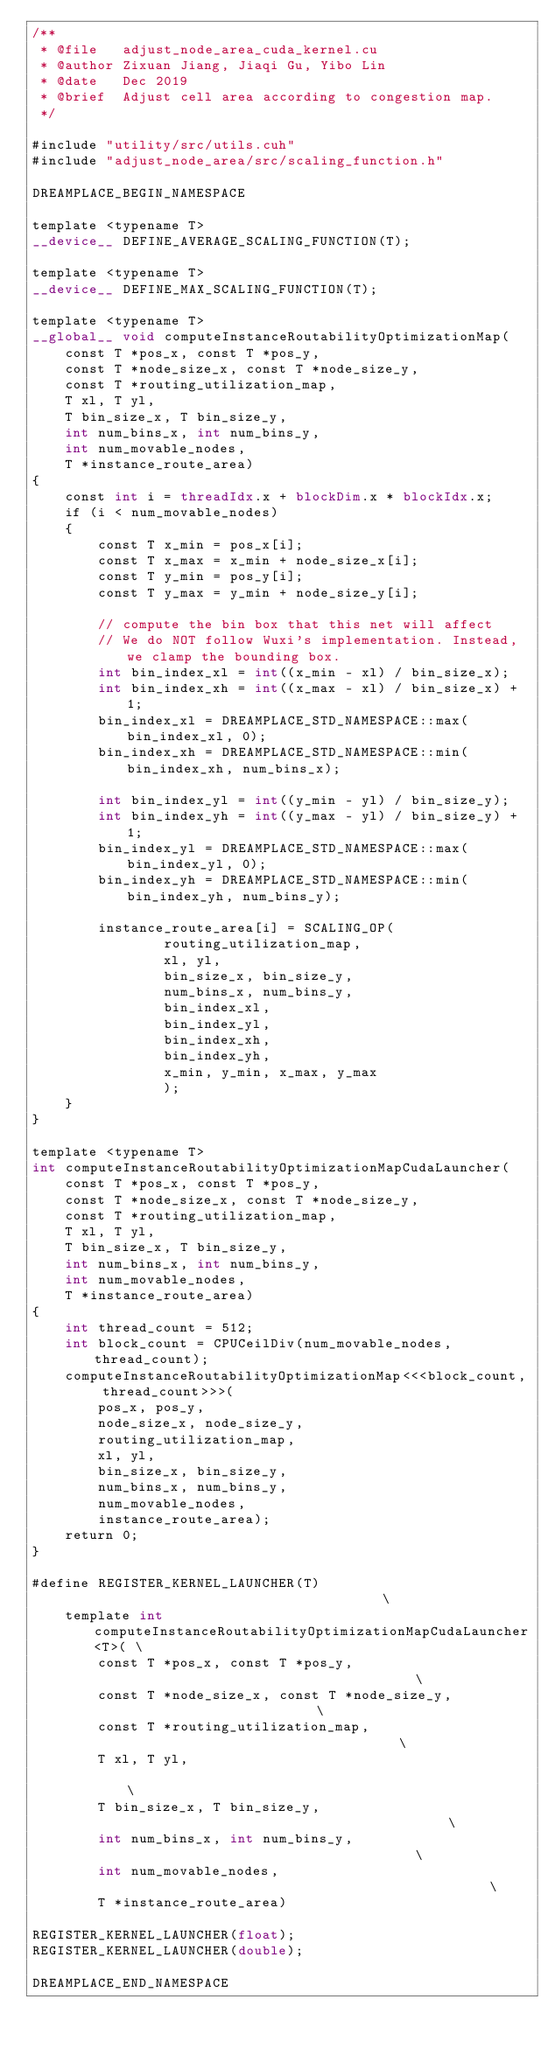<code> <loc_0><loc_0><loc_500><loc_500><_Cuda_>/**
 * @file   adjust_node_area_cuda_kernel.cu
 * @author Zixuan Jiang, Jiaqi Gu, Yibo Lin
 * @date   Dec 2019
 * @brief  Adjust cell area according to congestion map.
 */

#include "utility/src/utils.cuh"
#include "adjust_node_area/src/scaling_function.h"

DREAMPLACE_BEGIN_NAMESPACE

template <typename T>
__device__ DEFINE_AVERAGE_SCALING_FUNCTION(T); 

template <typename T>
__device__ DEFINE_MAX_SCALING_FUNCTION(T); 

template <typename T>
__global__ void computeInstanceRoutabilityOptimizationMap(
    const T *pos_x, const T *pos_y,
    const T *node_size_x, const T *node_size_y,
    const T *routing_utilization_map,
    T xl, T yl,
    T bin_size_x, T bin_size_y,
    int num_bins_x, int num_bins_y,
    int num_movable_nodes,
    T *instance_route_area)
{
    const int i = threadIdx.x + blockDim.x * blockIdx.x;
    if (i < num_movable_nodes)
    {
        const T x_min = pos_x[i];
        const T x_max = x_min + node_size_x[i];
        const T y_min = pos_y[i];
        const T y_max = y_min + node_size_y[i];

        // compute the bin box that this net will affect
        // We do NOT follow Wuxi's implementation. Instead, we clamp the bounding box.
        int bin_index_xl = int((x_min - xl) / bin_size_x);
        int bin_index_xh = int((x_max - xl) / bin_size_x) + 1;
        bin_index_xl = DREAMPLACE_STD_NAMESPACE::max(bin_index_xl, 0);
        bin_index_xh = DREAMPLACE_STD_NAMESPACE::min(bin_index_xh, num_bins_x);

        int bin_index_yl = int((y_min - yl) / bin_size_y);
        int bin_index_yh = int((y_max - yl) / bin_size_y) + 1;
        bin_index_yl = DREAMPLACE_STD_NAMESPACE::max(bin_index_yl, 0);
        bin_index_yh = DREAMPLACE_STD_NAMESPACE::min(bin_index_yh, num_bins_y);

        instance_route_area[i] = SCALING_OP(
                routing_utilization_map, 
                xl, yl, 
                bin_size_x, bin_size_y, 
                num_bins_x, num_bins_y, 
                bin_index_xl, 
                bin_index_yl, 
                bin_index_xh, 
                bin_index_yh, 
                x_min, y_min, x_max, y_max
                );
    }
}

template <typename T>
int computeInstanceRoutabilityOptimizationMapCudaLauncher(
    const T *pos_x, const T *pos_y,
    const T *node_size_x, const T *node_size_y,
    const T *routing_utilization_map,
    T xl, T yl,
    T bin_size_x, T bin_size_y,
    int num_bins_x, int num_bins_y,
    int num_movable_nodes,
    T *instance_route_area)
{
    int thread_count = 512;
    int block_count = CPUCeilDiv(num_movable_nodes, thread_count);
    computeInstanceRoutabilityOptimizationMap<<<block_count, thread_count>>>(
        pos_x, pos_y,
        node_size_x, node_size_y,
        routing_utilization_map,
        xl, yl,
        bin_size_x, bin_size_y,
        num_bins_x, num_bins_y,
        num_movable_nodes,
        instance_route_area);
    return 0;
}

#define REGISTER_KERNEL_LAUNCHER(T)                                        \
    template int computeInstanceRoutabilityOptimizationMapCudaLauncher<T>( \
        const T *pos_x, const T *pos_y,                                    \
        const T *node_size_x, const T *node_size_y,                        \
        const T *routing_utilization_map,                                  \
        T xl, T yl,                                                        \
        T bin_size_x, T bin_size_y,                                        \
        int num_bins_x, int num_bins_y,                                    \
        int num_movable_nodes,                                             \
        T *instance_route_area)

REGISTER_KERNEL_LAUNCHER(float);
REGISTER_KERNEL_LAUNCHER(double);

DREAMPLACE_END_NAMESPACE
</code> 